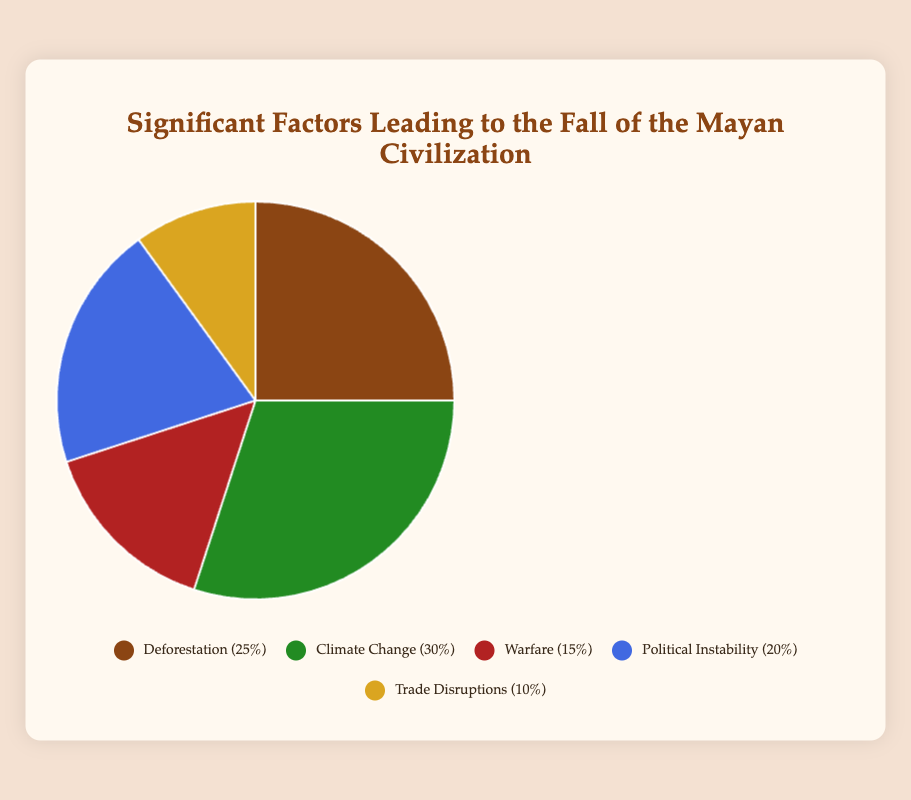What is the largest contributing factor to the fall of the Mayan Civilization? The pie chart shows the factors leading to the fall of the Mayan Civilization with their respective contribution percentages. The largest slice represents "Climate Change" at 30%.
Answer: Climate Change Which two factors contribute equally to the fall of the Mayan Civilization? The pie chart lists contribution percentages, and both "Deforestation" and "Political Instability" are shown to contribute 25% and 20% respectively. Find two factors with the same percentage.
Answer: None How much more does Climate Change contribute compared to Trade Disruptions? The pie chart shows contributions of Climate Change (30%) and Trade Disruptions (10%). Subtract the smaller percentage from the larger one: 30% - 10% = 20%.
Answer: 20% Which factor, contributing 15%, is depicted in the pie chart, and what is its visual color? The pie chart displays contributions and their associated colors. The factor with a 15% contribution is "Warfare," represented in red.
Answer: Warfare, red If you combine the contributions of Deforestation and Warfare, what percentage of the total does that represent? Add the percentages for Deforestation (25%) and Warfare (15%) from the pie chart: 25% + 15% = 40%.
Answer: 40% By what percentage does Political Instability exceed Trade Disruptions? The pie chart shows Political Instability at 20% and Trade Disruptions at 10%. Subtract the smaller percentage from the larger one: 20% - 10% = 10%.
Answer: 10% What color represents Climate Change, and what percentage of the total does it account for? The pie chart assigns colors to each factor. Climate Change is represented by green and accounts for 30%.
Answer: green, 30% Which two factors together make up half of the contribution to the fall? Examine the pie chart and add the contributions of the two factors. Climate Change (30%) and Deforestation (25%) together make up 55%, while Warfare (15%) and Political Instability (20%) make up 35%. No two factors exactly add up to 50%.
Answer: None How much do Warfare and Political Instability contribute combined? Add the percentages for Warfare (15%) and Political Instability (20%) from the pie chart: 15% + 20% = 35%.
Answer: 35% Which factor has the least contribution, and what is its percentage? The pie chart shows the contribution percentages. "Trade Disruptions" has the smallest percentage at 10%.
Answer: Trade Disruptions, 10% 